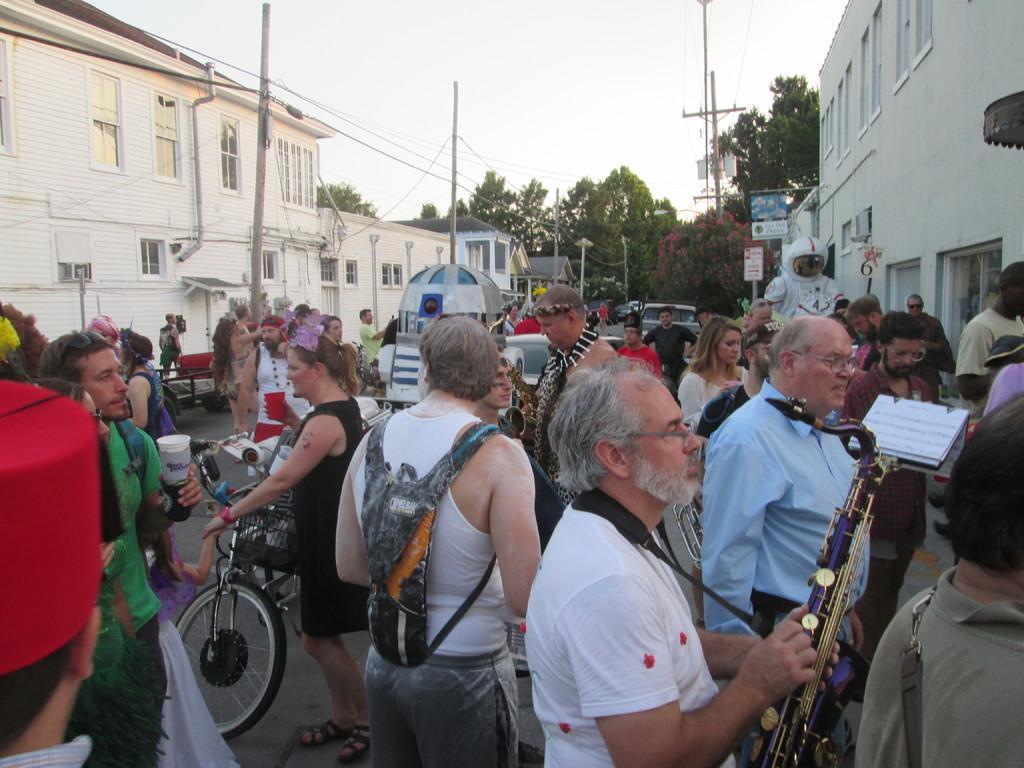Can you describe this image briefly? In this image there are people standing on a road and there are vehicles, on either side of the road there are buildings, poles, in the background there are trees and the sky. 